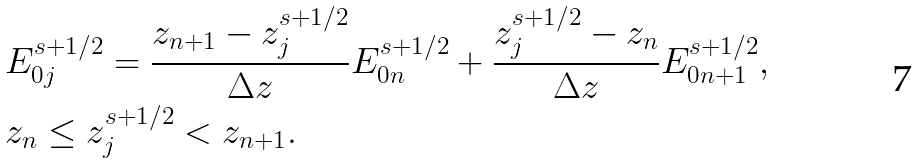<formula> <loc_0><loc_0><loc_500><loc_500>& E _ { 0 j } ^ { s + 1 / 2 } = \frac { z _ { n + 1 } - z _ { j } ^ { s + 1 / 2 } } { \Delta z } E _ { 0 n } ^ { s + 1 / 2 } + \frac { z _ { j } ^ { s + 1 / 2 } - z _ { n } } { \Delta z } E _ { 0 n + 1 } ^ { s + 1 / 2 } , \\ & z _ { n } \leq z _ { j } ^ { s + 1 / 2 } < z _ { n + 1 } . \\</formula> 